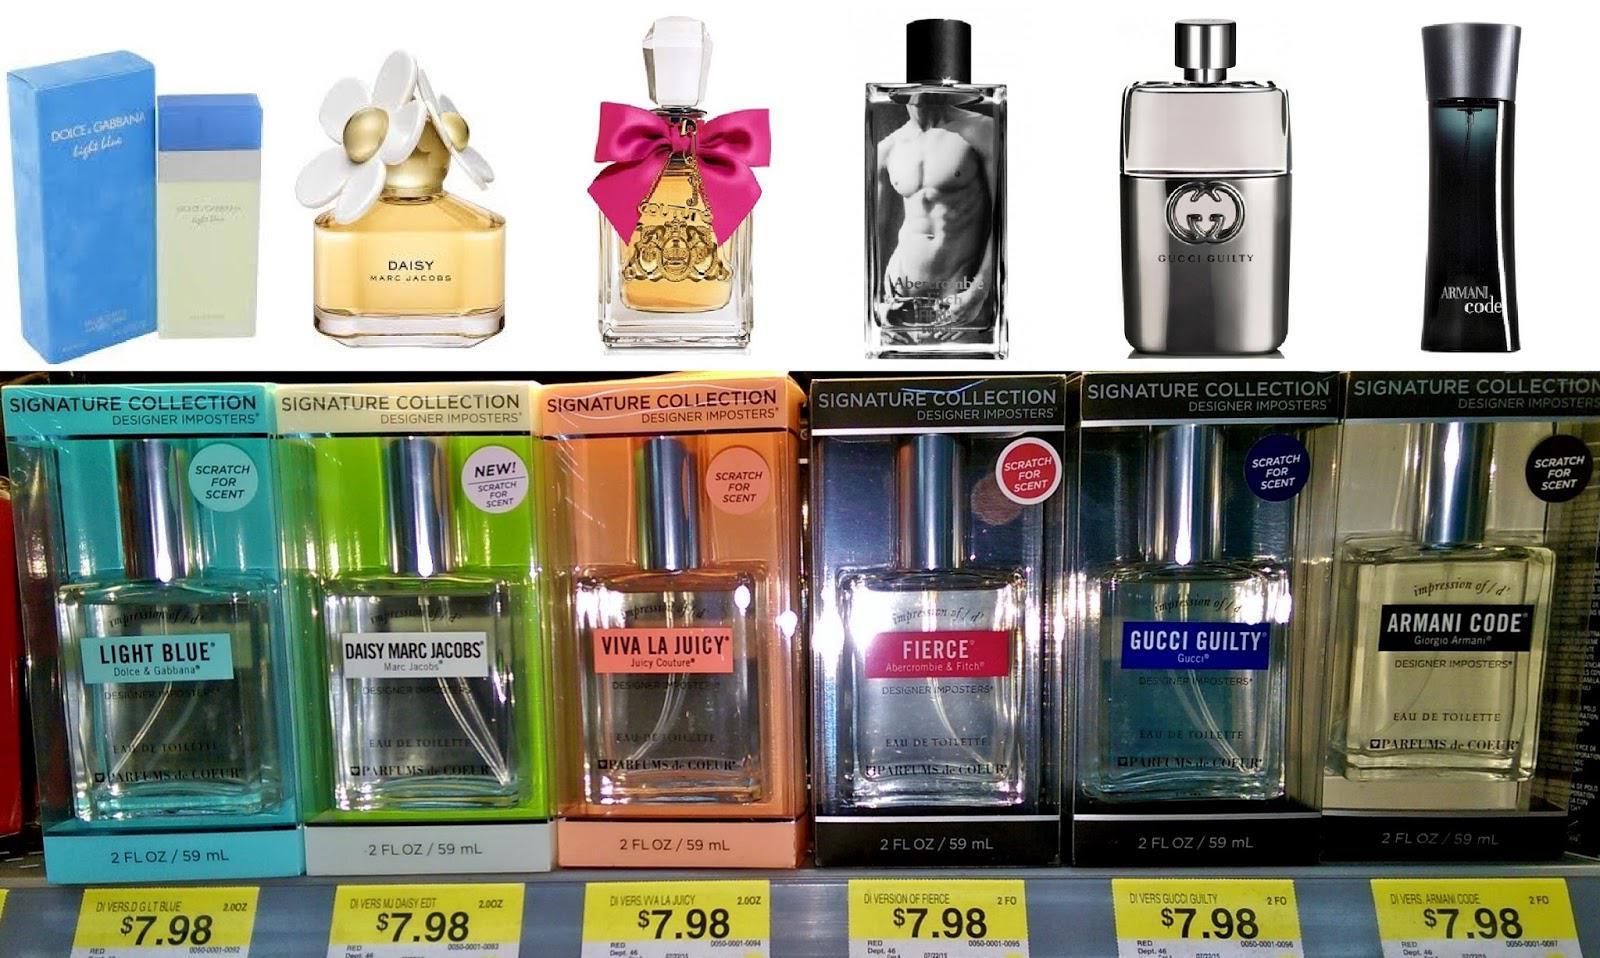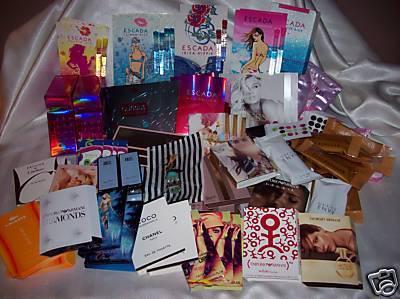The first image is the image on the left, the second image is the image on the right. Assess this claim about the two images: "The left image includes a horizontal row of at least five bottles of the same size and shape, but in different fragrance varieties.". Correct or not? Answer yes or no. Yes. The first image is the image on the left, the second image is the image on the right. For the images shown, is this caption "A person is holding a product." true? Answer yes or no. No. 